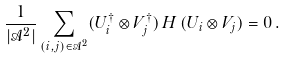Convert formula to latex. <formula><loc_0><loc_0><loc_500><loc_500>\frac { 1 } { | \mathcal { A } ^ { 2 } | } \sum _ { ( i , j ) \in \mathcal { A } ^ { 2 } } ( U _ { i } ^ { \dagger } \otimes V _ { j } ^ { \dagger } ) \, H \, ( U _ { i } \otimes V _ { j } ) = 0 \, .</formula> 